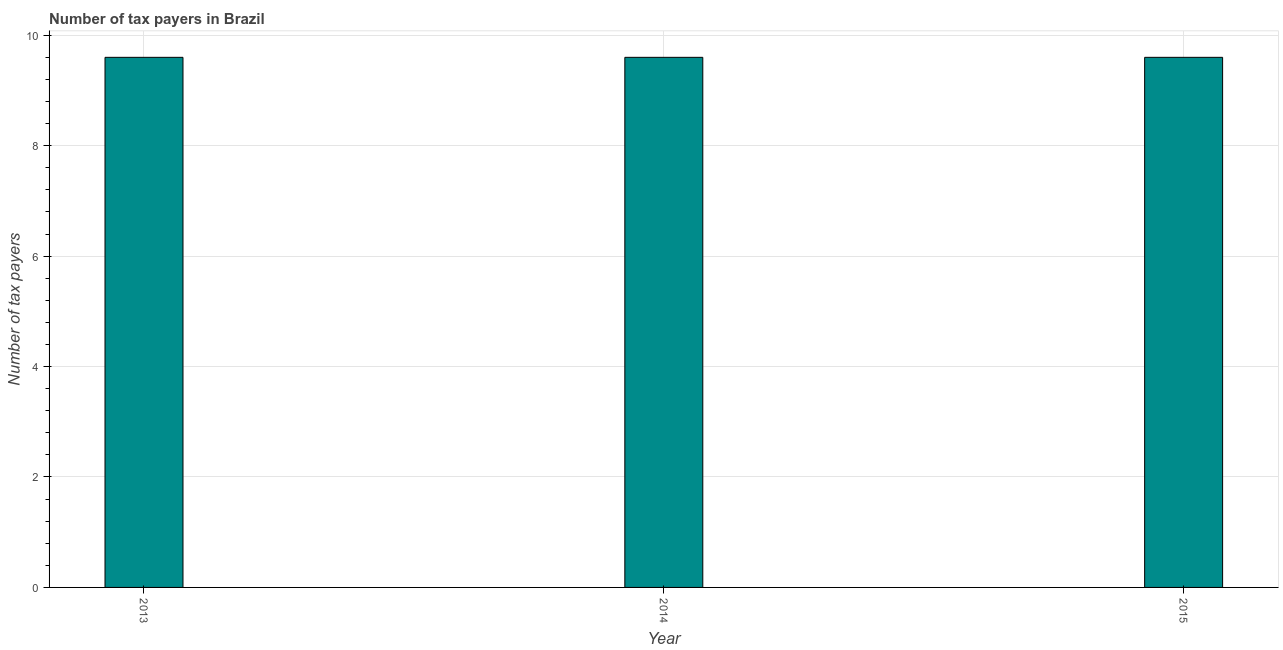Does the graph contain grids?
Your answer should be very brief. Yes. What is the title of the graph?
Provide a short and direct response. Number of tax payers in Brazil. What is the label or title of the Y-axis?
Ensure brevity in your answer.  Number of tax payers. What is the number of tax payers in 2013?
Provide a succinct answer. 9.6. Across all years, what is the minimum number of tax payers?
Give a very brief answer. 9.6. In which year was the number of tax payers minimum?
Ensure brevity in your answer.  2013. What is the sum of the number of tax payers?
Make the answer very short. 28.8. What is the median number of tax payers?
Provide a succinct answer. 9.6. In how many years, is the number of tax payers greater than 7.6 ?
Provide a short and direct response. 3. Do a majority of the years between 2015 and 2013 (inclusive) have number of tax payers greater than 5.2 ?
Your answer should be compact. Yes. What is the difference between the highest and the second highest number of tax payers?
Your answer should be very brief. 0. In how many years, is the number of tax payers greater than the average number of tax payers taken over all years?
Your response must be concise. 0. How many bars are there?
Ensure brevity in your answer.  3. Are all the bars in the graph horizontal?
Ensure brevity in your answer.  No. How many years are there in the graph?
Make the answer very short. 3. What is the difference between two consecutive major ticks on the Y-axis?
Make the answer very short. 2. Are the values on the major ticks of Y-axis written in scientific E-notation?
Give a very brief answer. No. What is the Number of tax payers of 2013?
Offer a terse response. 9.6. What is the Number of tax payers in 2015?
Your response must be concise. 9.6. What is the difference between the Number of tax payers in 2014 and 2015?
Offer a terse response. 0. What is the ratio of the Number of tax payers in 2013 to that in 2014?
Provide a short and direct response. 1. What is the ratio of the Number of tax payers in 2013 to that in 2015?
Your response must be concise. 1. What is the ratio of the Number of tax payers in 2014 to that in 2015?
Make the answer very short. 1. 